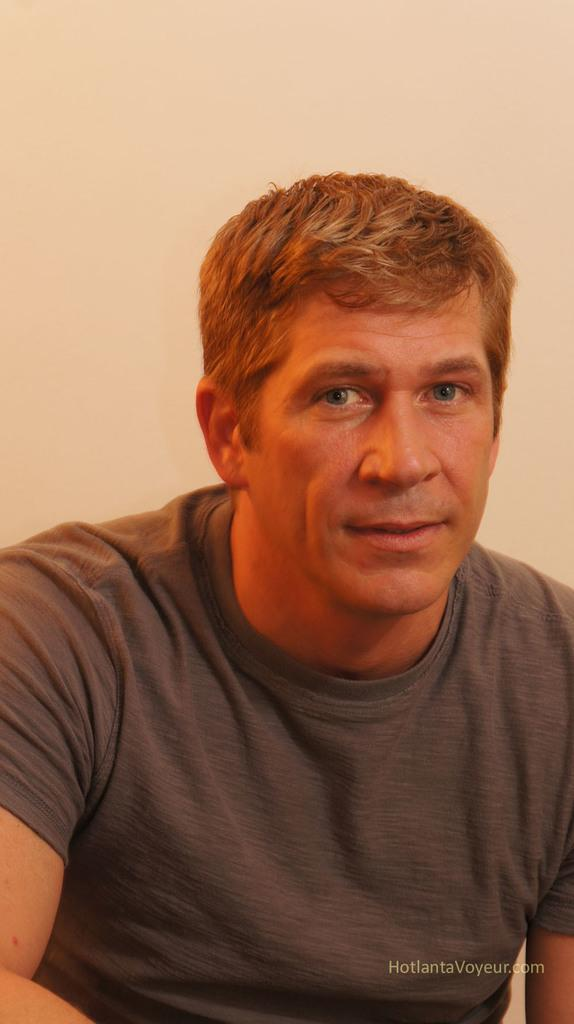What is the main subject of the image? There is a man in the image. What is the man wearing? The man is wearing a grey t-shirt. What is the man's facial expression? The man is smiling. What can be seen behind the man? There is a wall behind the man. How many snakes are present in the image? There are no snakes present in the image; it features a man wearing a grey t-shirt and smiling. What type of bun is the manager eating in the image? There is no manager or bun present in the image. 